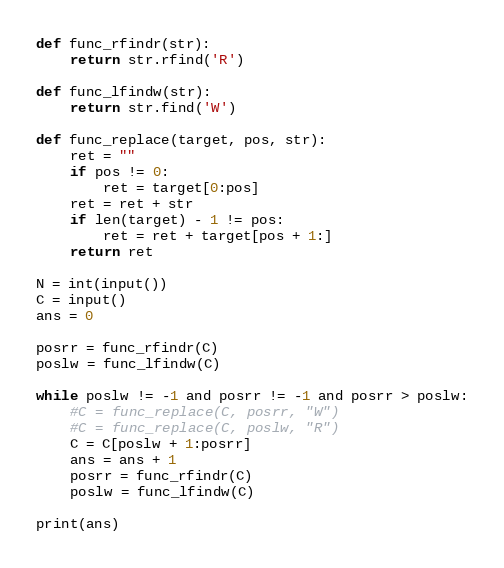<code> <loc_0><loc_0><loc_500><loc_500><_Python_>def func_rfindr(str):
    return str.rfind('R')

def func_lfindw(str):
    return str.find('W')

def func_replace(target, pos, str):
    ret = ""
    if pos != 0:
        ret = target[0:pos]
    ret = ret + str
    if len(target) - 1 != pos:
        ret = ret + target[pos + 1:]
    return ret

N = int(input())
C = input()
ans = 0

posrr = func_rfindr(C)
poslw = func_lfindw(C)

while poslw != -1 and posrr != -1 and posrr > poslw:
    #C = func_replace(C, posrr, "W")
    #C = func_replace(C, poslw, "R")
    C = C[poslw + 1:posrr]
    ans = ans + 1
    posrr = func_rfindr(C)
    poslw = func_lfindw(C)

print(ans)</code> 